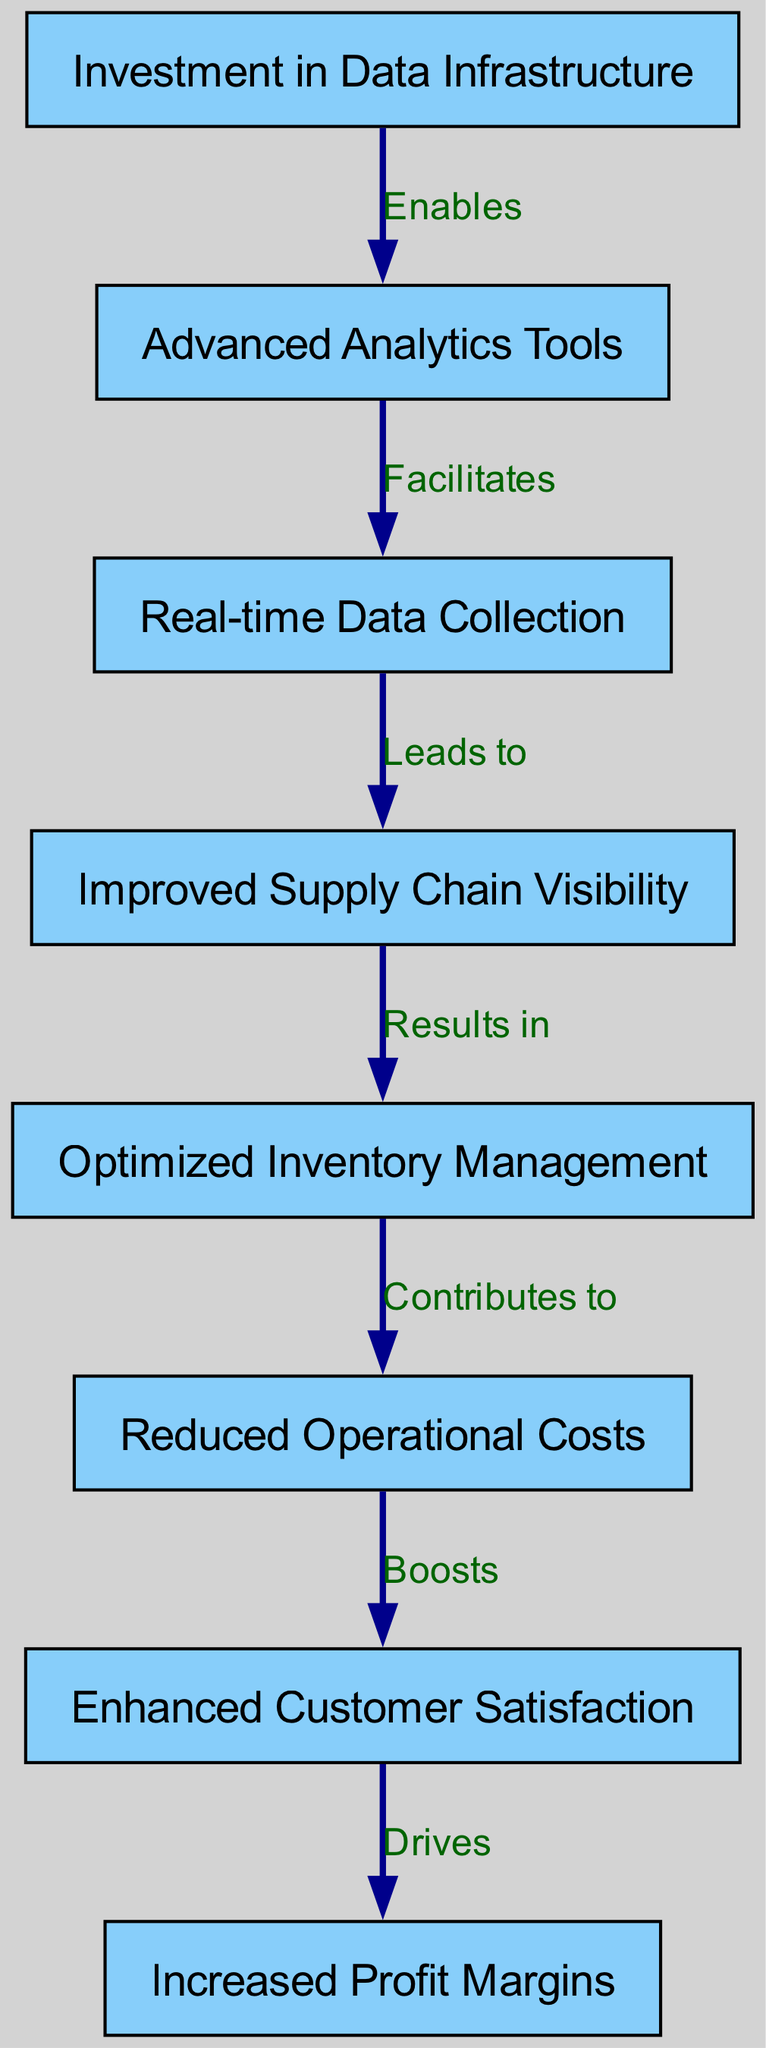What is the total number of nodes in the diagram? The number of nodes can be counted by listing them: Investment in Data Infrastructure, Advanced Analytics Tools, Real-time Data Collection, Improved Supply Chain Visibility, Optimized Inventory Management, Reduced Operational Costs, Enhanced Customer Satisfaction, Increased Profit Margins. There are 8 nodes in total.
Answer: 8 What label is associated with the edge from node 3 to node 4? The edge from Real-time Data Collection (node 3) to Improved Supply Chain Visibility (node 4) is labeled "Leads to." This can be seen directly from the diagram's edge labels.
Answer: Leads to Which node directly contributes to Reduced Operational Costs? Reduced Operational Costs (node 6) is directly contributed to by Optimized Inventory Management (node 5), as indicated by the arrow from node 5 leading to node 6.
Answer: Optimized Inventory Management What is the relationship between Investment in Data Infrastructure and Advanced Analytics Tools? The relationship is one of enablement. The diagram states that Investment in Data Infrastructure (node 1) "Enables" Advanced Analytics Tools (node 2), showing a direct functional connection between these nodes.
Answer: Enables How many edges are in the diagram? To find the total number of edges, we can count them: 7 edges connect the 8 nodes to represent the relationships. Listing them shows connections between each successive node.
Answer: 7 What is the final outcome observed in the flow of the diagram? The flow leads to Increased Profit Margins (node 8) as the final endpoint. Following the chain, it can be deduced that enhanced customer satisfaction (node 7) drives profits, which is the culmination of the preceding nodes’ contributions.
Answer: Increased Profit Margins Which node leads to Improved Supply Chain Visibility? Real-time Data Collection (node 3) leads to Improved Supply Chain Visibility (node 4) as indicated by the directed edge labeled "Leads to." This connection showcases how the flow of information supports visibility within the supply chain.
Answer: Real-time Data Collection What boosts Enhanced Customer Satisfaction? Reduced Operational Costs (node 6) boosts Enhanced Customer Satisfaction (node 7), according to the diagram. This suggests that operational efficiency directly influences customer contentment, leading to better experiences.
Answer: Reduced Operational Costs 